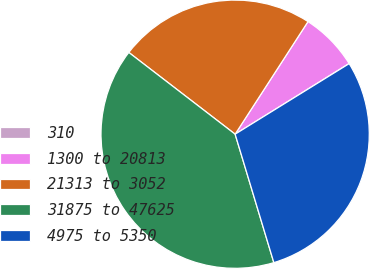<chart> <loc_0><loc_0><loc_500><loc_500><pie_chart><fcel>310<fcel>1300 to 20813<fcel>21313 to 3052<fcel>31875 to 47625<fcel>4975 to 5350<nl><fcel>0.02%<fcel>7.02%<fcel>23.71%<fcel>40.09%<fcel>29.16%<nl></chart> 